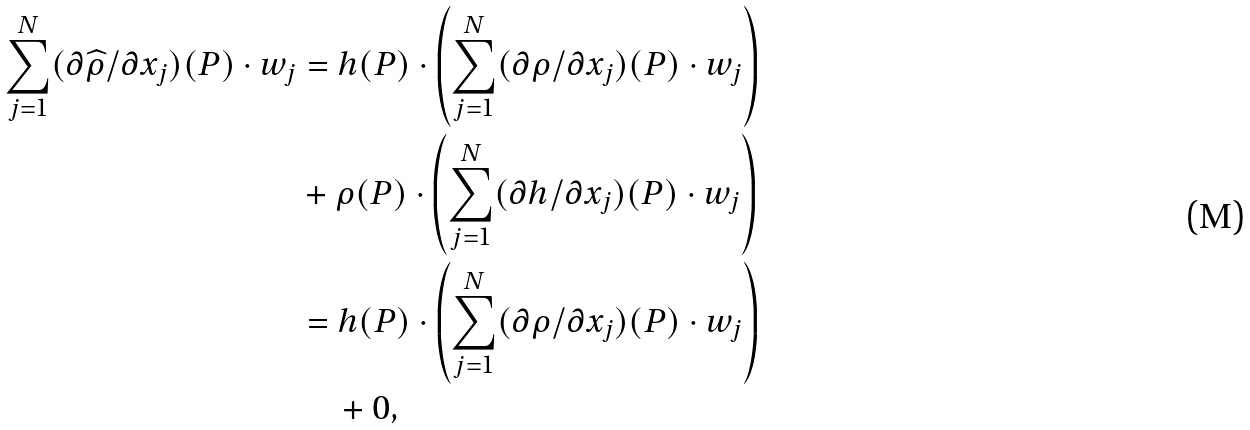Convert formula to latex. <formula><loc_0><loc_0><loc_500><loc_500>\sum _ { j = 1 } ^ { N } ( \partial \widehat { \rho } / \partial x _ { j } ) ( P ) \cdot w _ { j } & = h ( P ) \cdot \left ( \sum _ { j = 1 } ^ { N } ( \partial \rho / \partial x _ { j } ) ( P ) \cdot w _ { j } \right ) \\ & + \rho ( P ) \cdot \left ( \sum _ { j = 1 } ^ { N } ( \partial h / \partial x _ { j } ) ( P ) \cdot w _ { j } \right ) \\ & = h ( P ) \cdot \left ( \sum _ { j = 1 } ^ { N } ( \partial \rho / \partial x _ { j } ) ( P ) \cdot w _ { j } \right ) \\ & \quad + 0 , \\</formula> 